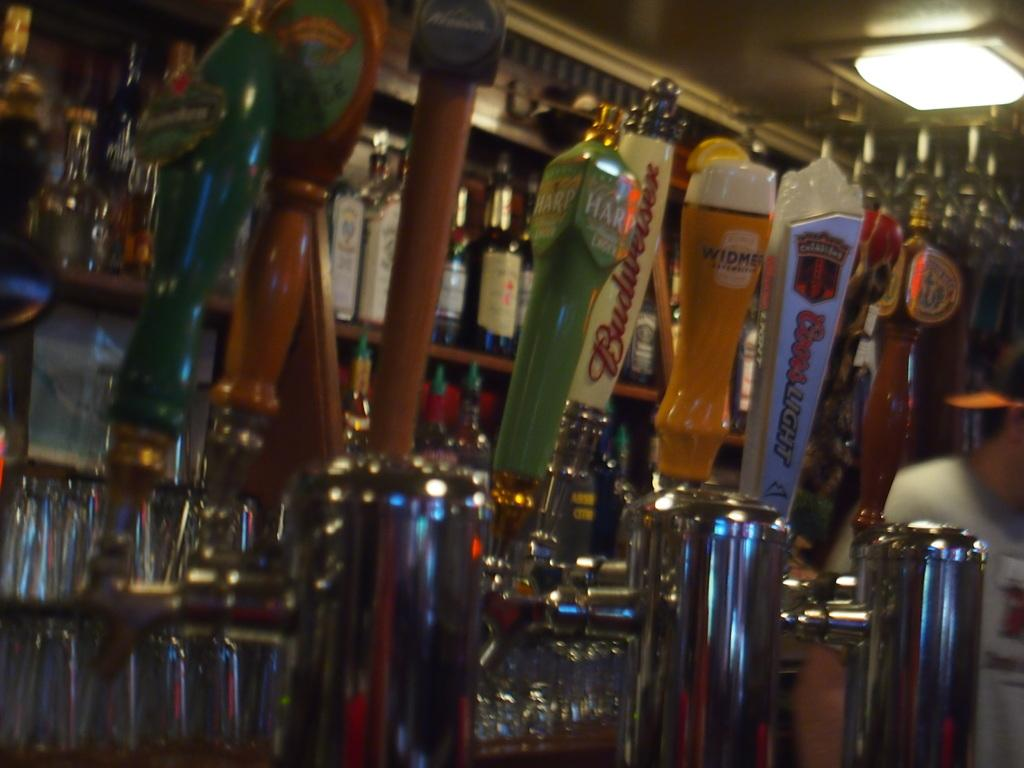What is on the rack in the image? The rack is filled with bottles. Can you describe the lighting in the image? There is a light on top of the rack. What type of cushion is used to control the trade in the image? There is no cushion, control, or trade present in the image. The image only features a rack filled with bottles and a light on top of the rack. 